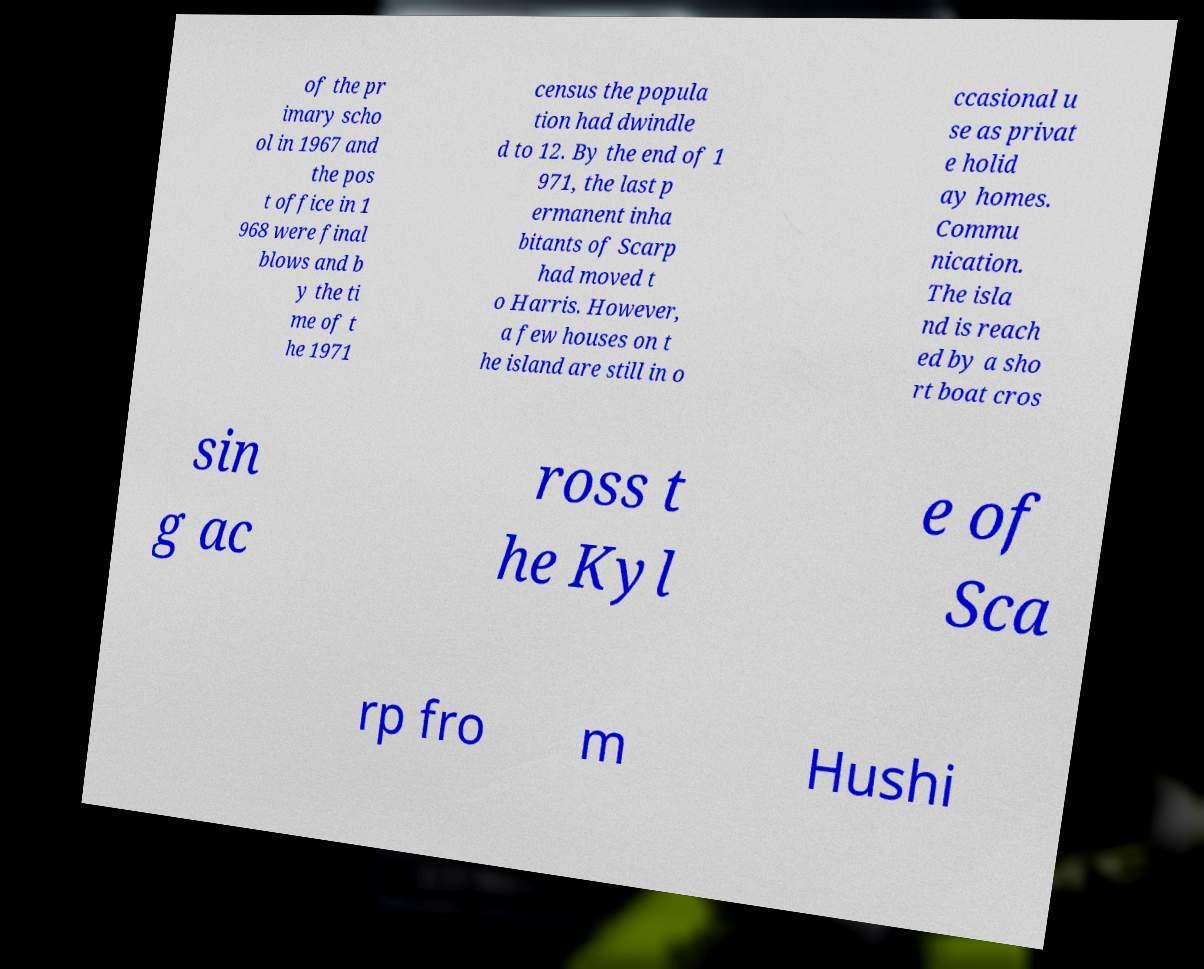What messages or text are displayed in this image? I need them in a readable, typed format. of the pr imary scho ol in 1967 and the pos t office in 1 968 were final blows and b y the ti me of t he 1971 census the popula tion had dwindle d to 12. By the end of 1 971, the last p ermanent inha bitants of Scarp had moved t o Harris. However, a few houses on t he island are still in o ccasional u se as privat e holid ay homes. Commu nication. The isla nd is reach ed by a sho rt boat cros sin g ac ross t he Kyl e of Sca rp fro m Hushi 